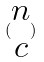Convert formula to latex. <formula><loc_0><loc_0><loc_500><loc_500>( \begin{matrix} n \\ c \end{matrix} )</formula> 